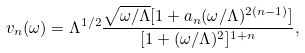Convert formula to latex. <formula><loc_0><loc_0><loc_500><loc_500>v _ { n } ( \omega ) = \Lambda ^ { 1 / 2 } \frac { \sqrt { \omega / \Lambda } [ 1 + a _ { n } ( \omega / \Lambda ) ^ { 2 ( n - 1 ) } ] } { [ 1 + ( \omega / \Lambda ) ^ { 2 } ] ^ { 1 + n } } ,</formula> 